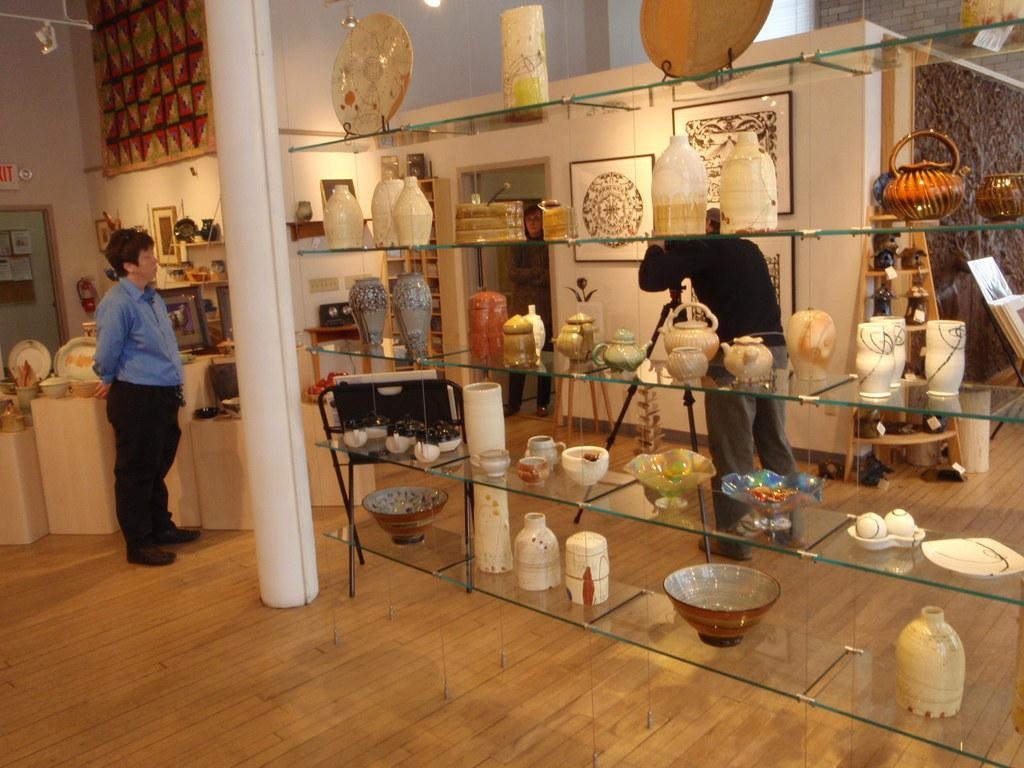What color is the floor in the image? The floor in the image is brown. What can be seen hanging on the wall in the image? There is a glass rack in the image. What type of objects are in the rack? There are glass objects in the rack. How many people are present in the image? Two men are standing in the image. What type of guide is the man holding in the image? There is no guide present in the image; the two men are standing without any visible objects in their hands. 